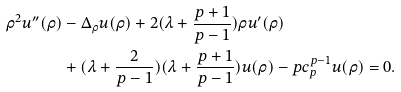Convert formula to latex. <formula><loc_0><loc_0><loc_500><loc_500>\rho ^ { 2 } u ^ { \prime \prime } ( \rho ) & - \Delta _ { \rho } u ( \rho ) + 2 ( \lambda + \frac { p + 1 } { p - 1 } ) \rho u ^ { \prime } ( \rho ) \\ & + ( \lambda + \frac { 2 } { p - 1 } ) ( \lambda + \frac { p + 1 } { p - 1 } ) u ( \rho ) - p c _ { p } ^ { p - 1 } u ( \rho ) = 0 .</formula> 